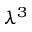Convert formula to latex. <formula><loc_0><loc_0><loc_500><loc_500>\lambda ^ { 3 }</formula> 